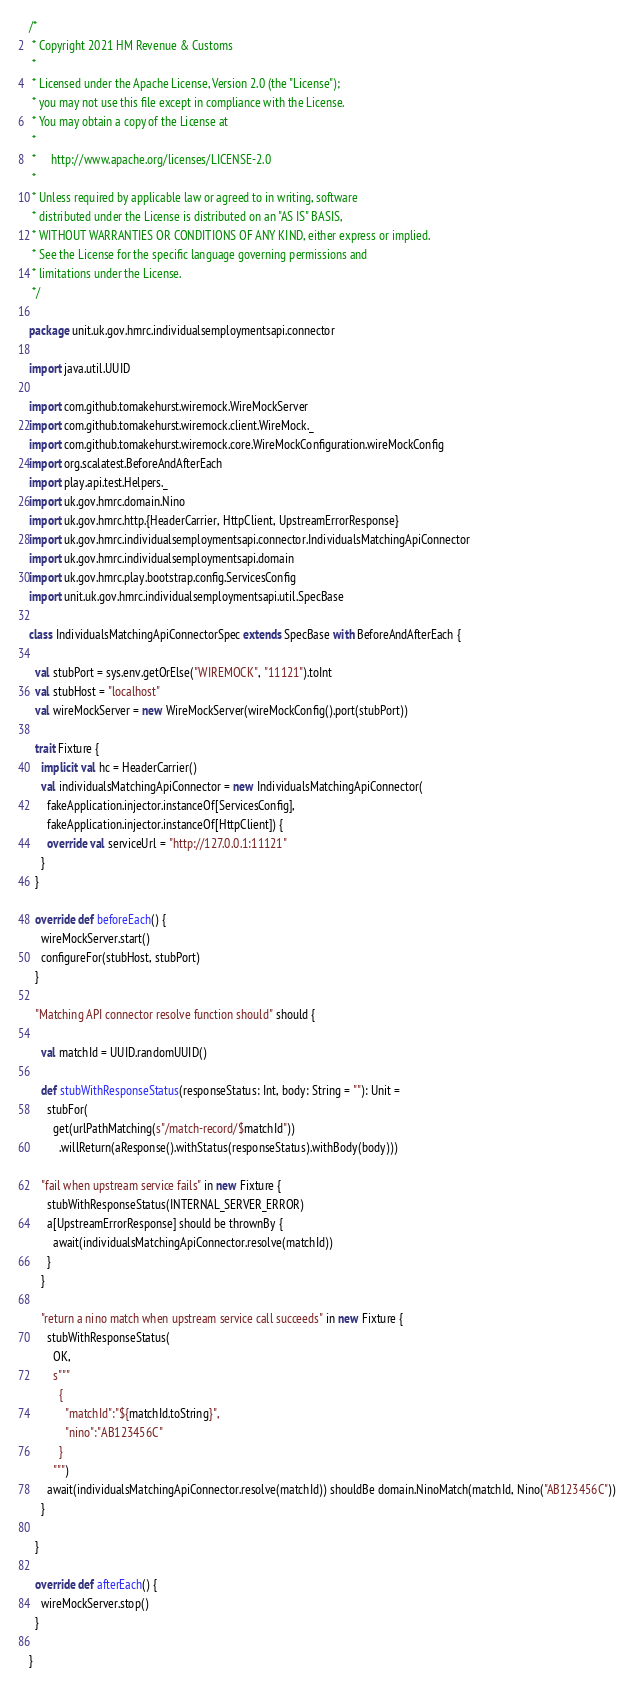<code> <loc_0><loc_0><loc_500><loc_500><_Scala_>/*
 * Copyright 2021 HM Revenue & Customs
 *
 * Licensed under the Apache License, Version 2.0 (the "License");
 * you may not use this file except in compliance with the License.
 * You may obtain a copy of the License at
 *
 *     http://www.apache.org/licenses/LICENSE-2.0
 *
 * Unless required by applicable law or agreed to in writing, software
 * distributed under the License is distributed on an "AS IS" BASIS,
 * WITHOUT WARRANTIES OR CONDITIONS OF ANY KIND, either express or implied.
 * See the License for the specific language governing permissions and
 * limitations under the License.
 */

package unit.uk.gov.hmrc.individualsemploymentsapi.connector

import java.util.UUID

import com.github.tomakehurst.wiremock.WireMockServer
import com.github.tomakehurst.wiremock.client.WireMock._
import com.github.tomakehurst.wiremock.core.WireMockConfiguration.wireMockConfig
import org.scalatest.BeforeAndAfterEach
import play.api.test.Helpers._
import uk.gov.hmrc.domain.Nino
import uk.gov.hmrc.http.{HeaderCarrier, HttpClient, UpstreamErrorResponse}
import uk.gov.hmrc.individualsemploymentsapi.connector.IndividualsMatchingApiConnector
import uk.gov.hmrc.individualsemploymentsapi.domain
import uk.gov.hmrc.play.bootstrap.config.ServicesConfig
import unit.uk.gov.hmrc.individualsemploymentsapi.util.SpecBase

class IndividualsMatchingApiConnectorSpec extends SpecBase with BeforeAndAfterEach {

  val stubPort = sys.env.getOrElse("WIREMOCK", "11121").toInt
  val stubHost = "localhost"
  val wireMockServer = new WireMockServer(wireMockConfig().port(stubPort))

  trait Fixture {
    implicit val hc = HeaderCarrier()
    val individualsMatchingApiConnector = new IndividualsMatchingApiConnector(
      fakeApplication.injector.instanceOf[ServicesConfig],
      fakeApplication.injector.instanceOf[HttpClient]) {
      override val serviceUrl = "http://127.0.0.1:11121"
    }
  }

  override def beforeEach() {
    wireMockServer.start()
    configureFor(stubHost, stubPort)
  }

  "Matching API connector resolve function should" should {

    val matchId = UUID.randomUUID()

    def stubWithResponseStatus(responseStatus: Int, body: String = ""): Unit =
      stubFor(
        get(urlPathMatching(s"/match-record/$matchId"))
          .willReturn(aResponse().withStatus(responseStatus).withBody(body)))

    "fail when upstream service fails" in new Fixture {
      stubWithResponseStatus(INTERNAL_SERVER_ERROR)
      a[UpstreamErrorResponse] should be thrownBy {
        await(individualsMatchingApiConnector.resolve(matchId))
      }
    }

    "return a nino match when upstream service call succeeds" in new Fixture {
      stubWithResponseStatus(
        OK,
        s"""
          {
            "matchId":"${matchId.toString}",
            "nino":"AB123456C"
          }
        """)
      await(individualsMatchingApiConnector.resolve(matchId)) shouldBe domain.NinoMatch(matchId, Nino("AB123456C"))
    }

  }

  override def afterEach() {
    wireMockServer.stop()
  }

}
</code> 